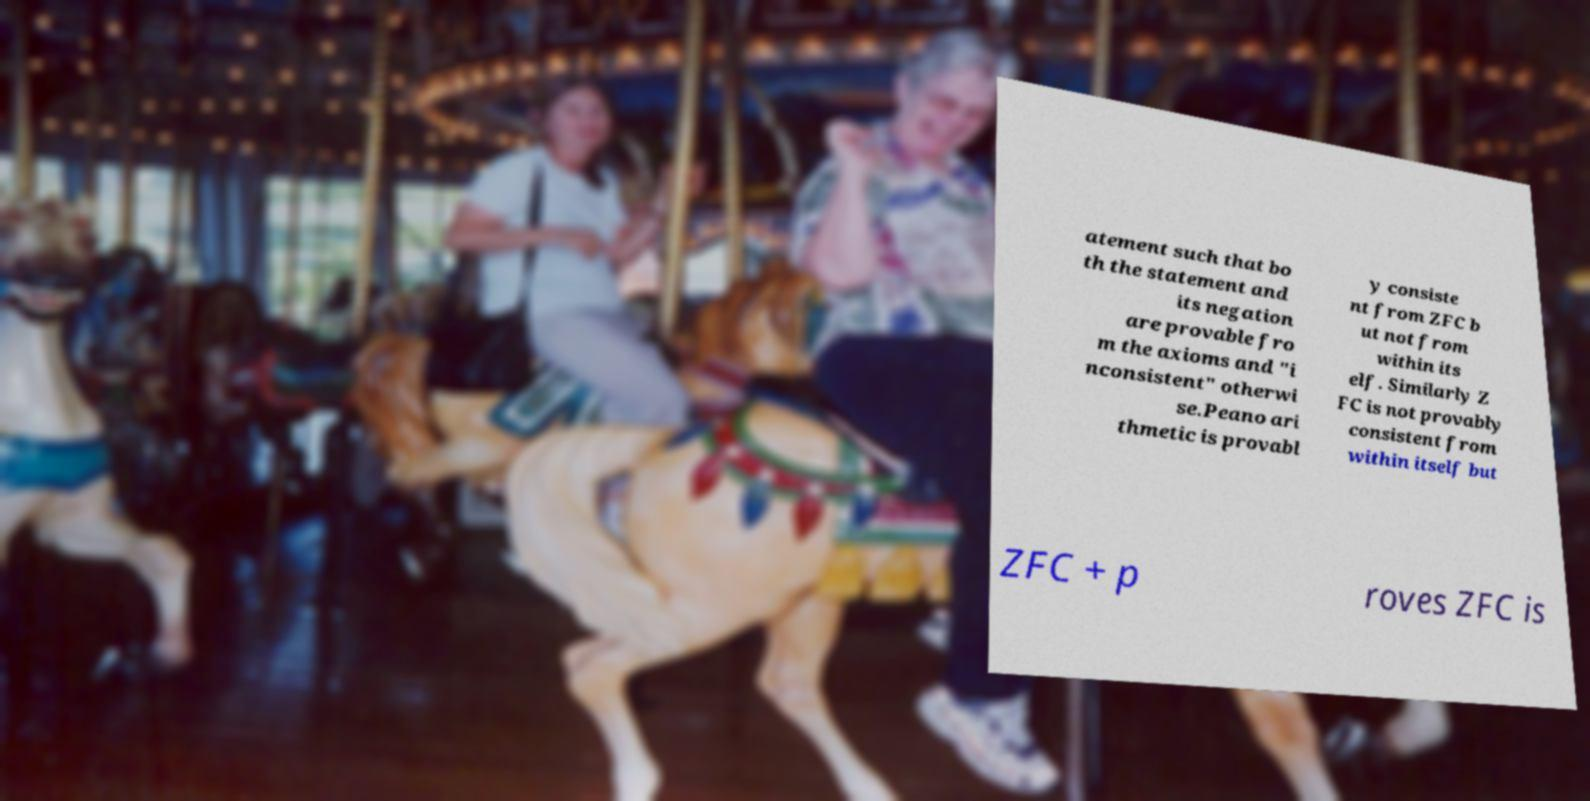I need the written content from this picture converted into text. Can you do that? atement such that bo th the statement and its negation are provable fro m the axioms and "i nconsistent" otherwi se.Peano ari thmetic is provabl y consiste nt from ZFC b ut not from within its elf. Similarly Z FC is not provably consistent from within itself but ZFC + p roves ZFC is 